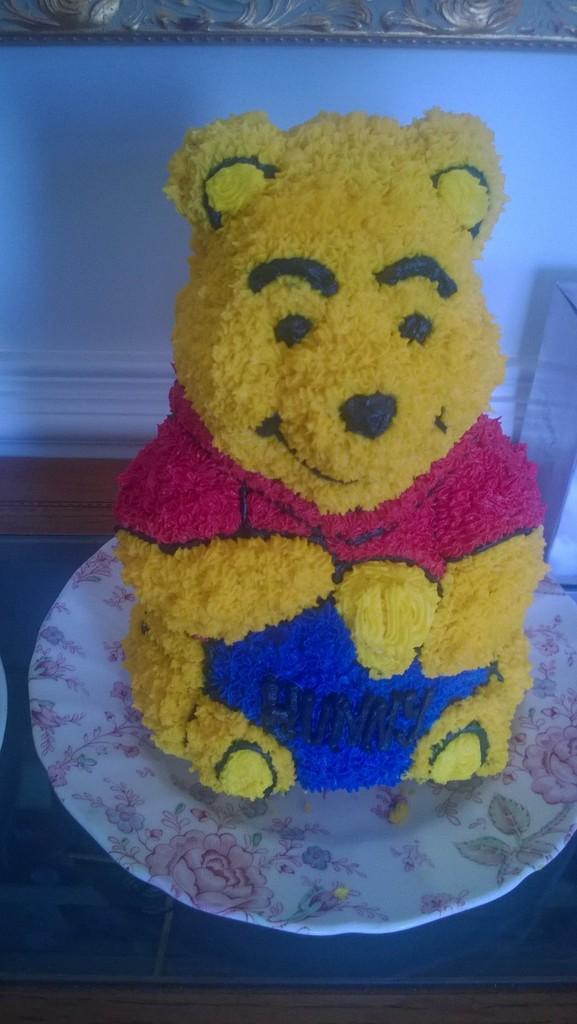Please provide a concise description of this image. In this image we can see a doll made with food items placed in a plate kept on the table. 